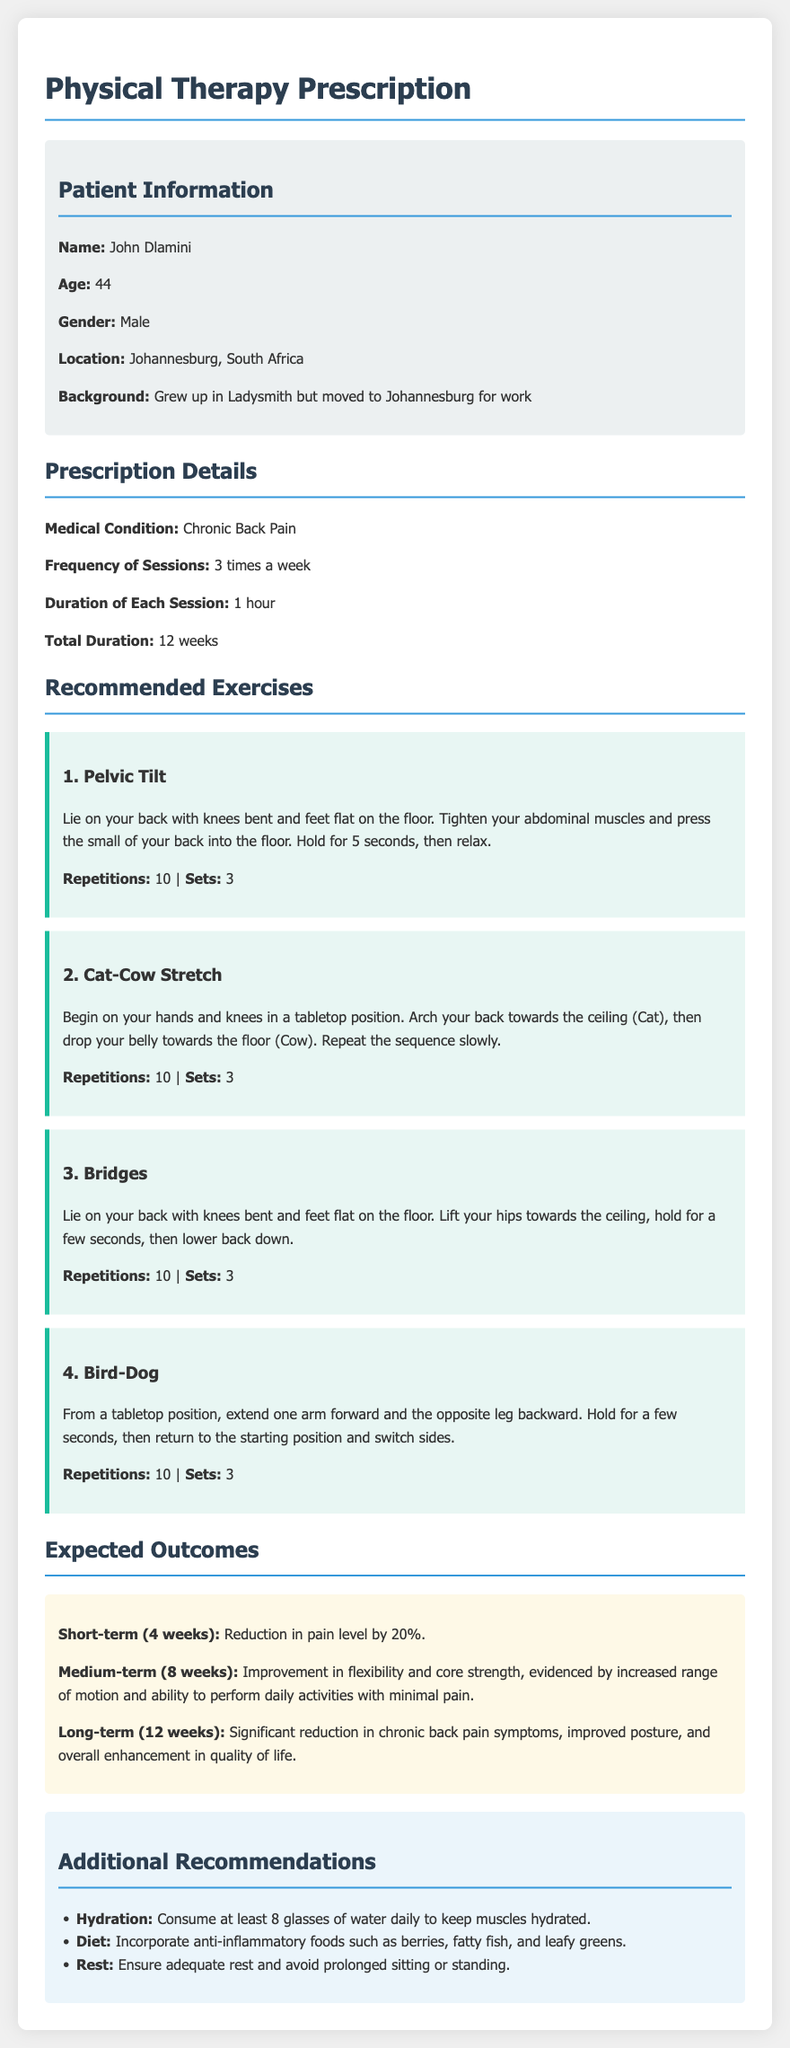What is the patient's name? The patient's name is mentioned in the patient information section, identifying John Dlamini as the individual.
Answer: John Dlamini How old is the patient? The patient's age is explicitly stated in the document.
Answer: 44 What is the frequency of therapy sessions? The document clearly specifies how often the sessions are to be attended.
Answer: 3 times a week What is the total duration of the therapy? Total duration is mentioned in the prescription details, indicating how long the therapy is planned.
Answer: 12 weeks What exercise involves lying on your back with knees bent? The document lists exercise descriptions to identify specific activities, particularly one that matches this description.
Answer: Pelvic Tilt How many repetitions are recommended for the Cat-Cow Stretch? The number of repetitions for this exercise is specified to guide the patient in their routine.
Answer: 10 What is the expected short-term outcome after 4 weeks? The expected outcomes section details specific goals to be achieved in different timeframes, particularly noting changes after 4 weeks.
Answer: Reduction in pain level by 20% What dietary advice is given? The additional recommendations section provides insights into managing health through food choices, specifically mentioning dietary strategies.
Answer: Incorporate anti-inflammatory foods What should the patient do to stay hydrated? The document suggests specific actions to promote hydration among other health recommendations.
Answer: Consume at least 8 glasses of water daily 